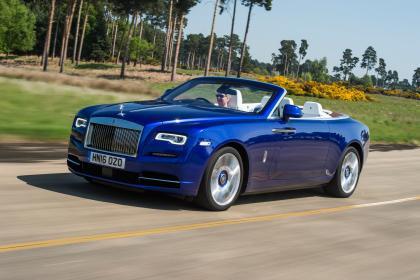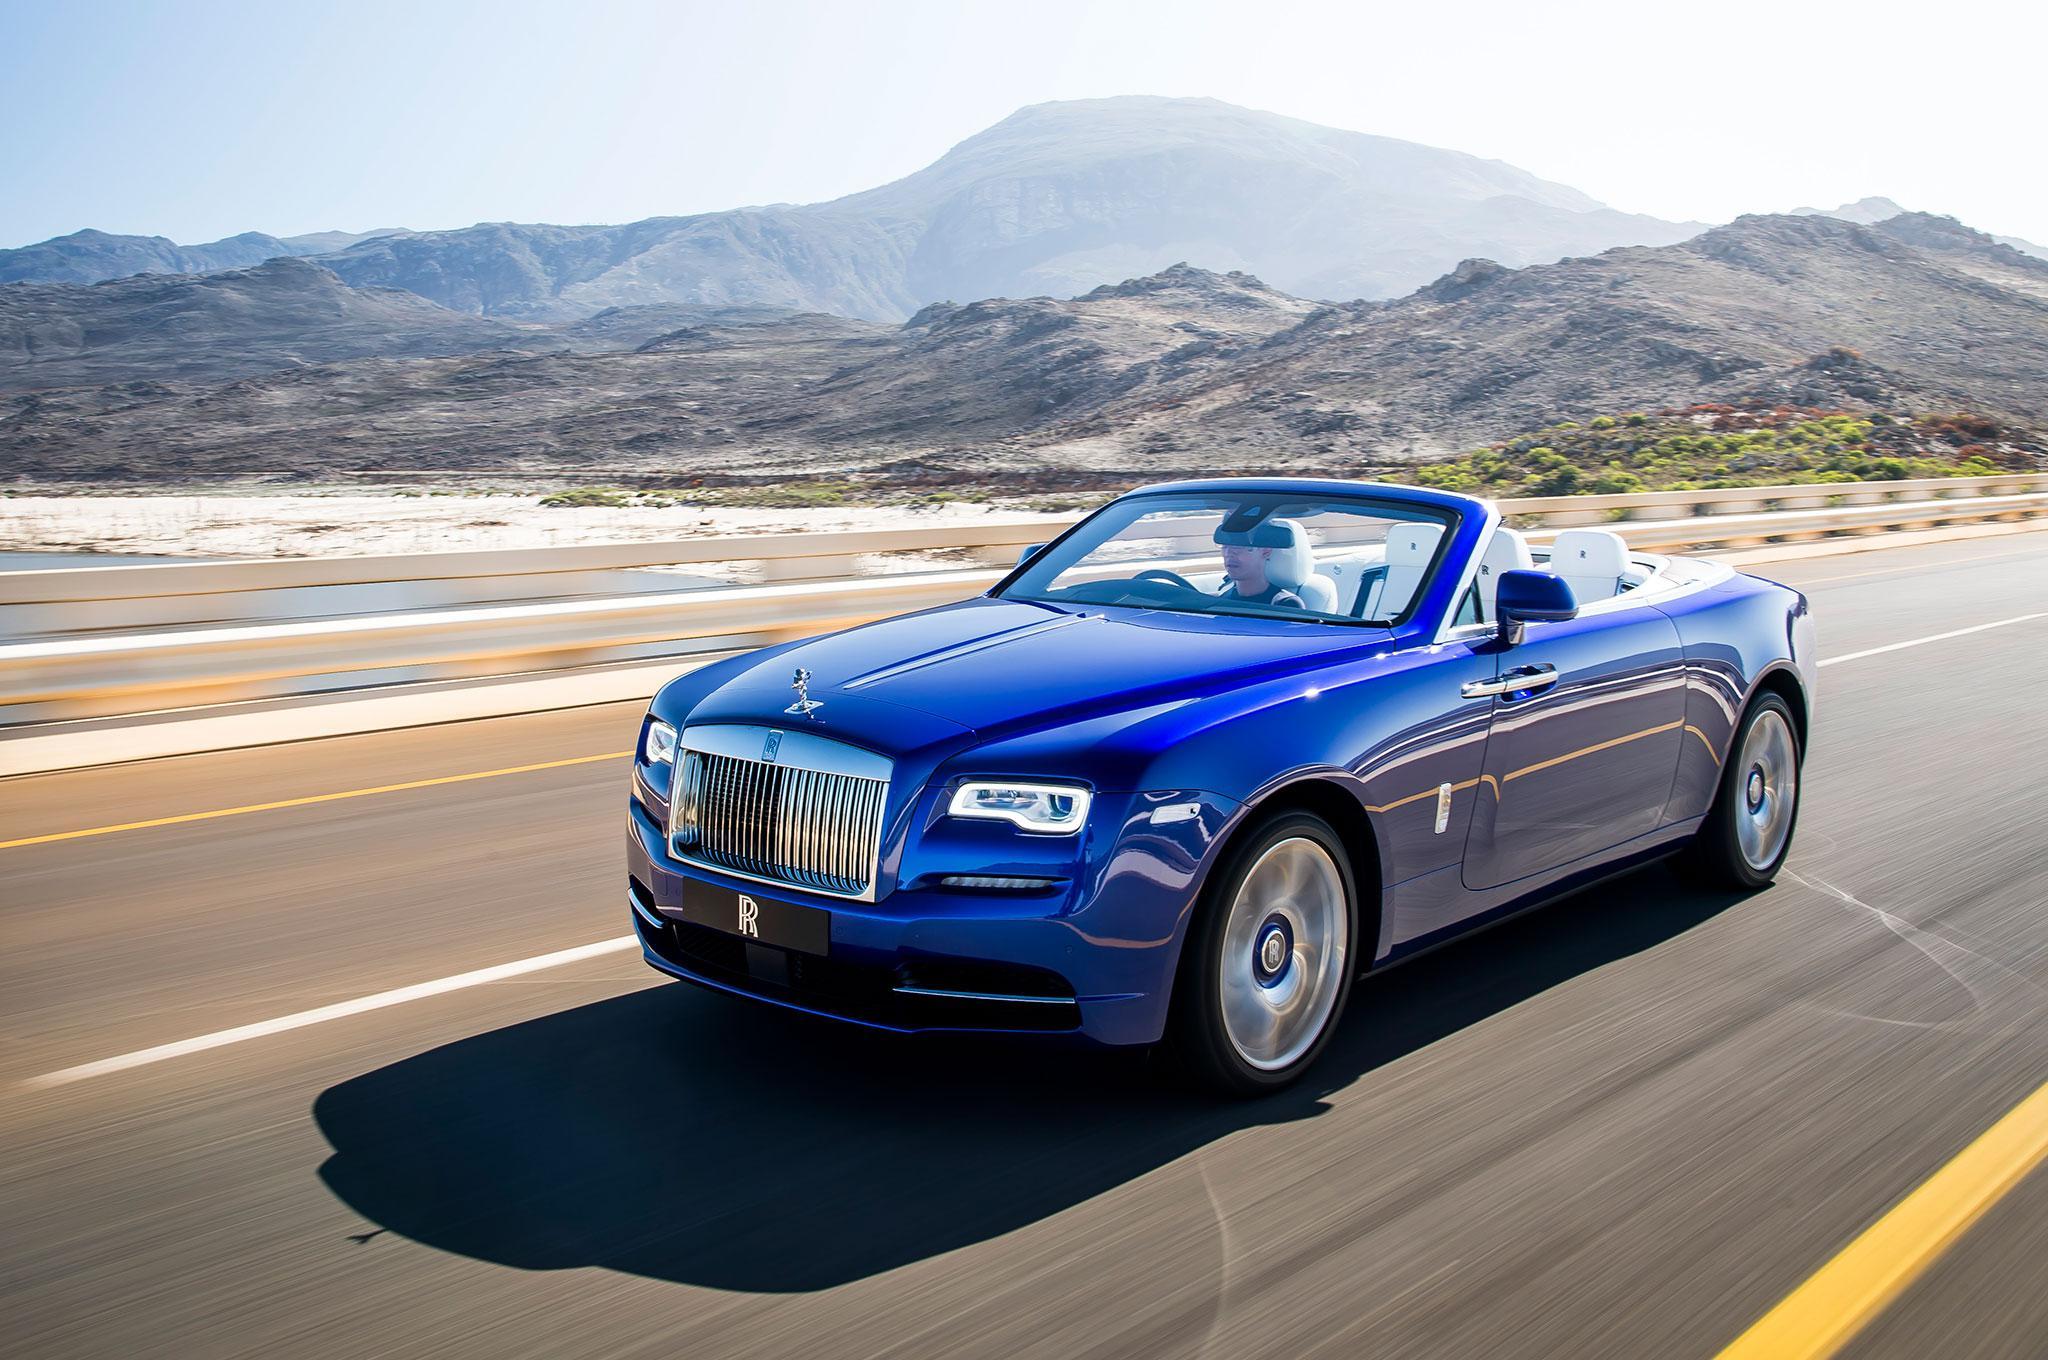The first image is the image on the left, the second image is the image on the right. Evaluate the accuracy of this statement regarding the images: "In each image there is a blue convertible that is facing the left.". Is it true? Answer yes or no. Yes. The first image is the image on the left, the second image is the image on the right. Examine the images to the left and right. Is the description "There is a car with brown seats." accurate? Answer yes or no. No. 